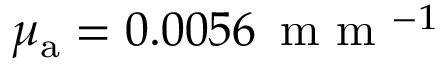<formula> <loc_0><loc_0><loc_500><loc_500>\mu _ { \mathrm a } = 0 . 0 0 5 6 \, m m ^ { - 1 }</formula> 